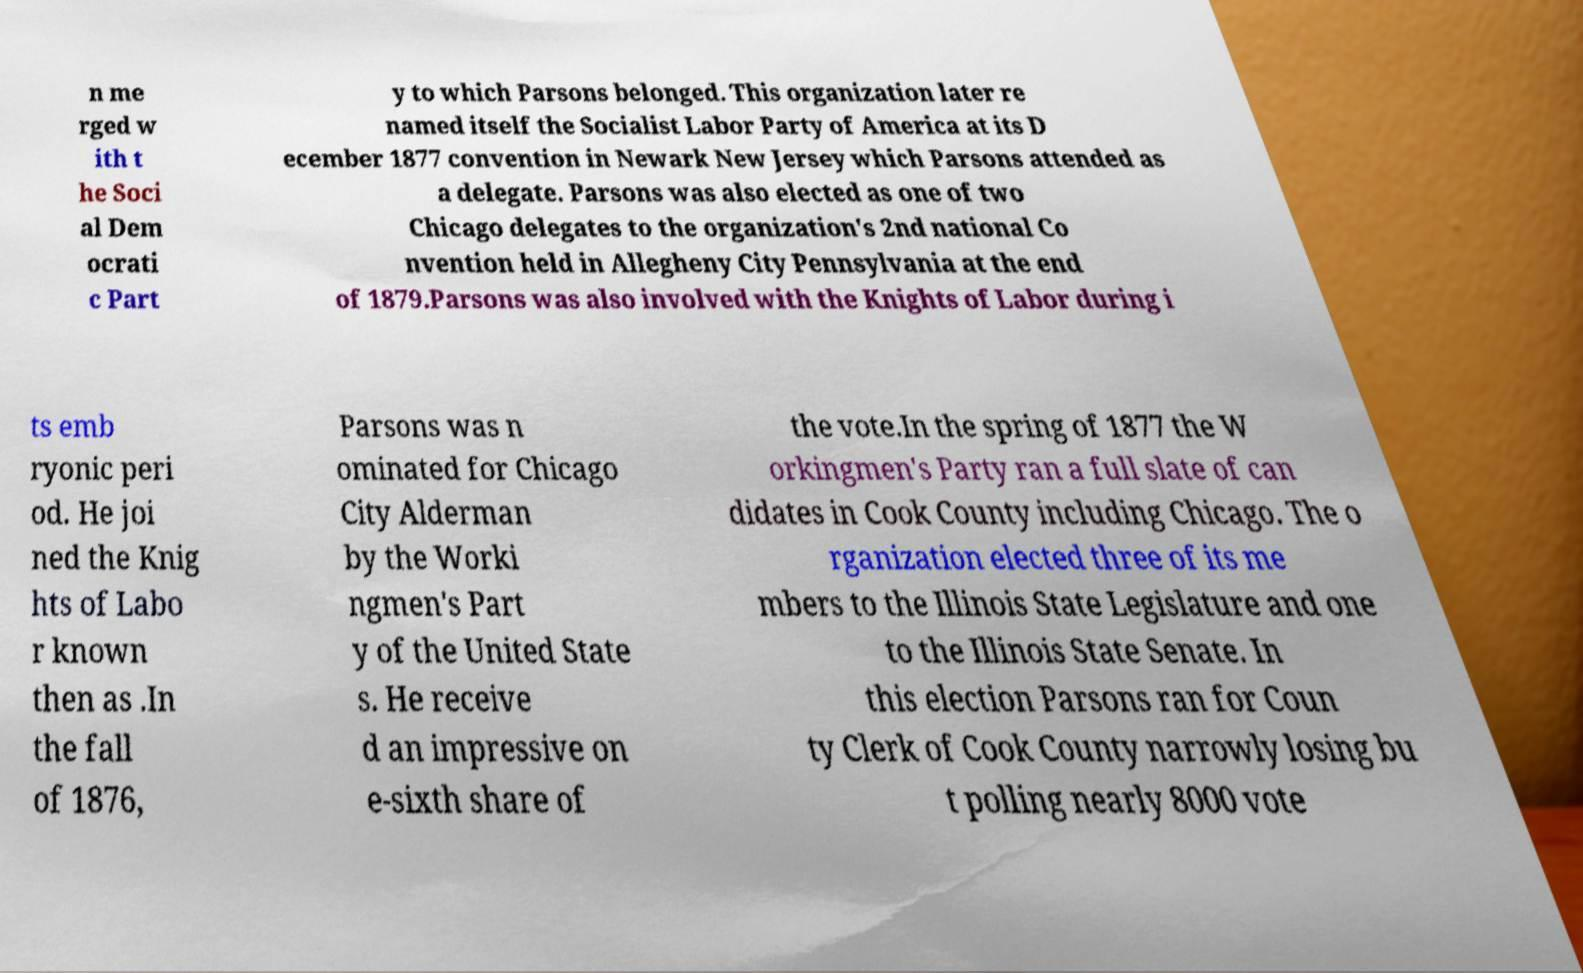There's text embedded in this image that I need extracted. Can you transcribe it verbatim? n me rged w ith t he Soci al Dem ocrati c Part y to which Parsons belonged. This organization later re named itself the Socialist Labor Party of America at its D ecember 1877 convention in Newark New Jersey which Parsons attended as a delegate. Parsons was also elected as one of two Chicago delegates to the organization's 2nd national Co nvention held in Allegheny City Pennsylvania at the end of 1879.Parsons was also involved with the Knights of Labor during i ts emb ryonic peri od. He joi ned the Knig hts of Labo r known then as .In the fall of 1876, Parsons was n ominated for Chicago City Alderman by the Worki ngmen's Part y of the United State s. He receive d an impressive on e-sixth share of the vote.In the spring of 1877 the W orkingmen's Party ran a full slate of can didates in Cook County including Chicago. The o rganization elected three of its me mbers to the Illinois State Legislature and one to the Illinois State Senate. In this election Parsons ran for Coun ty Clerk of Cook County narrowly losing bu t polling nearly 8000 vote 